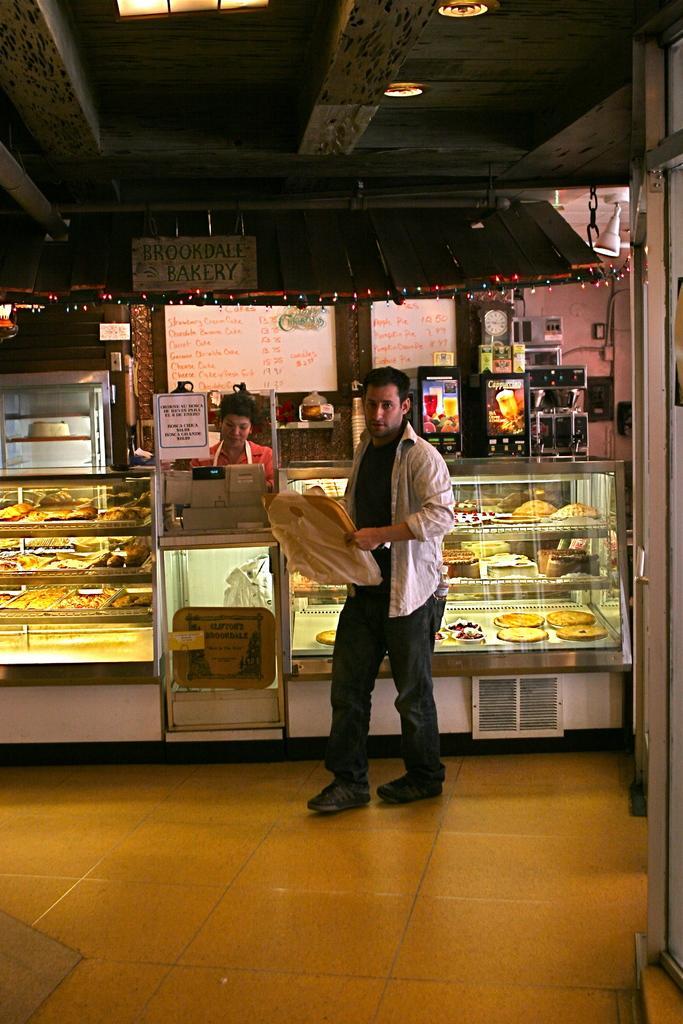How would you summarize this image in a sentence or two? There is a person standing and holding an object in his hands and there are few eatables and a person behind him. 